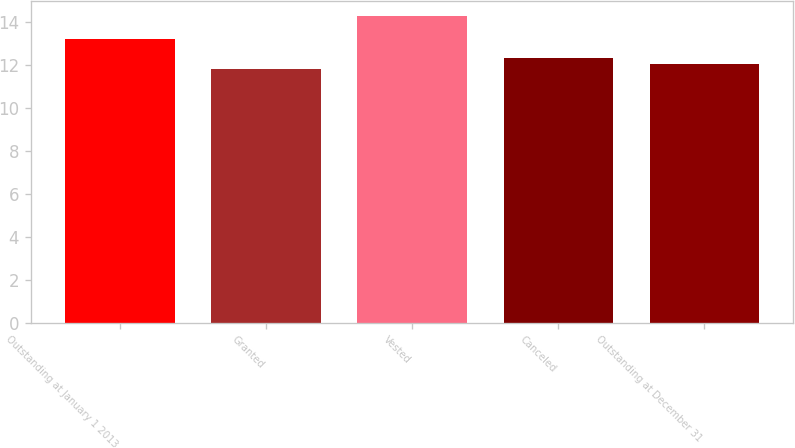Convert chart to OTSL. <chart><loc_0><loc_0><loc_500><loc_500><bar_chart><fcel>Outstanding at January 1 2013<fcel>Granted<fcel>Vested<fcel>Canceled<fcel>Outstanding at December 31<nl><fcel>13.18<fcel>11.8<fcel>14.24<fcel>12.29<fcel>12.05<nl></chart> 